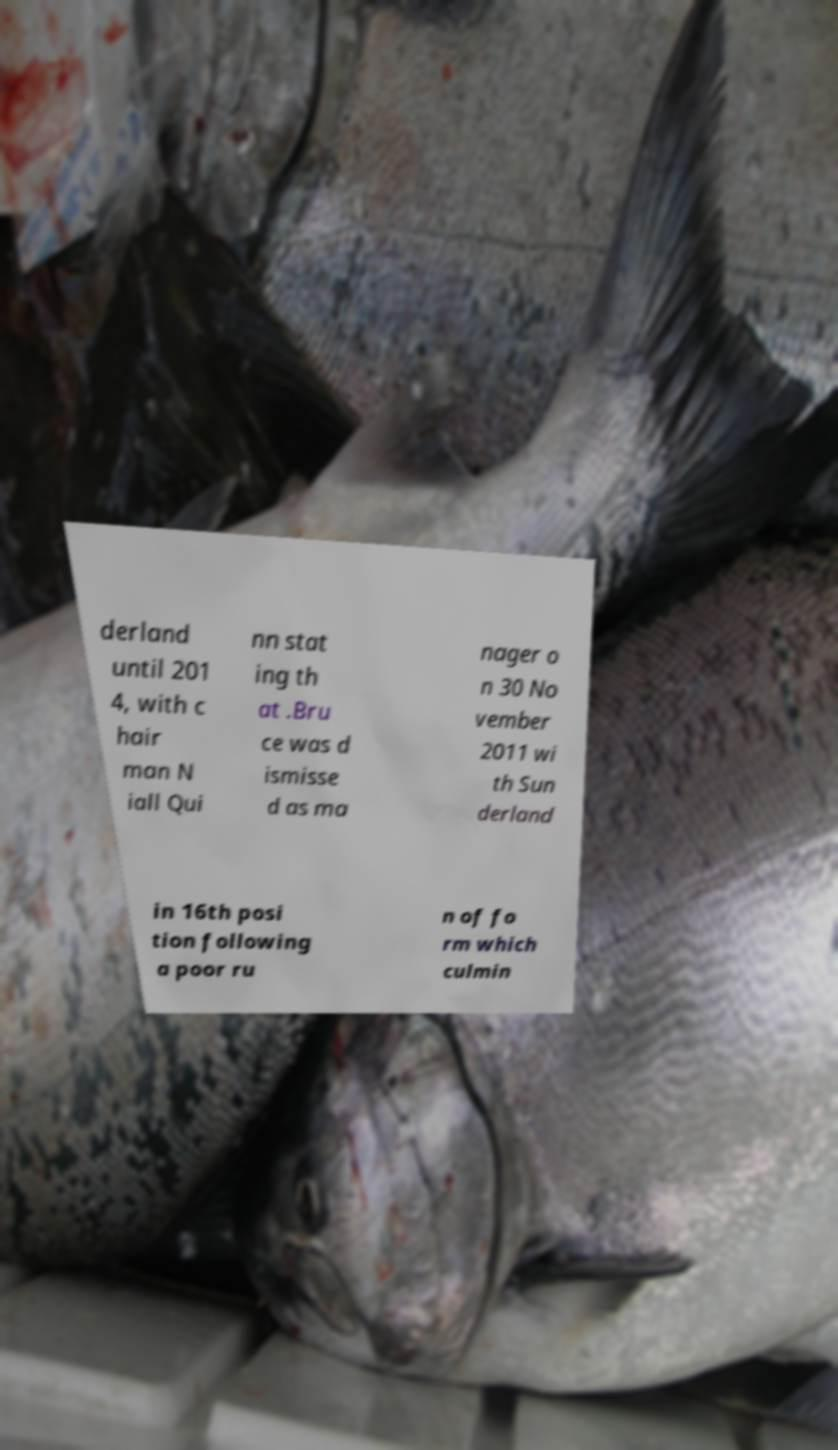Can you accurately transcribe the text from the provided image for me? derland until 201 4, with c hair man N iall Qui nn stat ing th at .Bru ce was d ismisse d as ma nager o n 30 No vember 2011 wi th Sun derland in 16th posi tion following a poor ru n of fo rm which culmin 